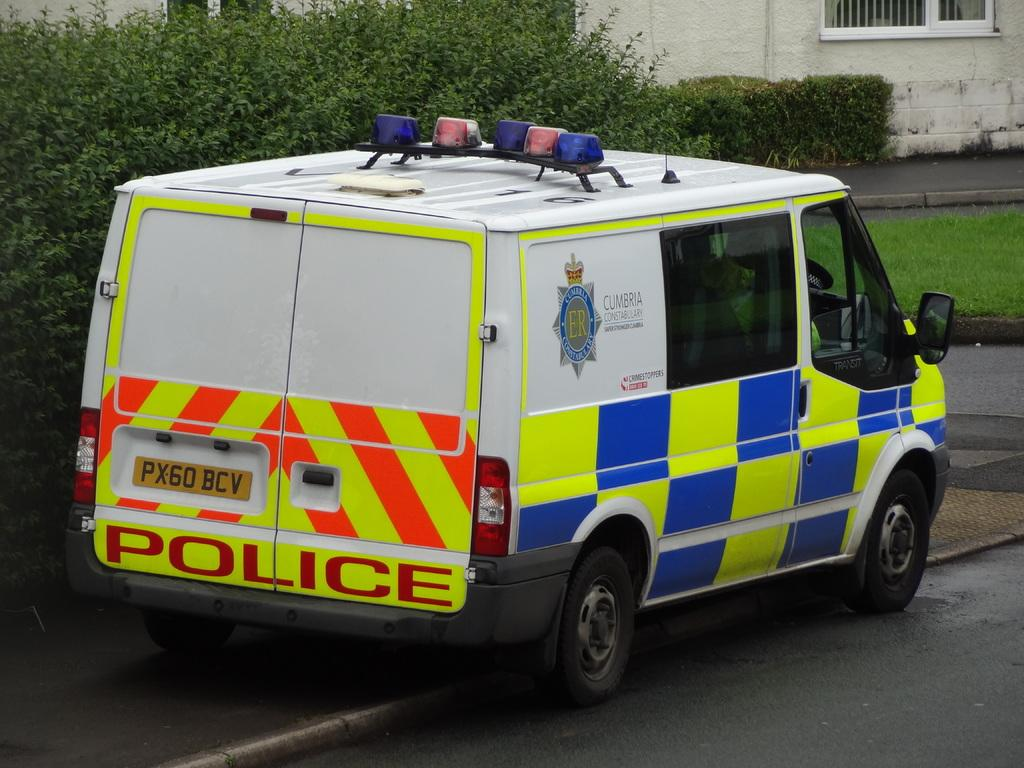<image>
Give a short and clear explanation of the subsequent image. A police mini bus with a license plate  number: PX60 BCV. 